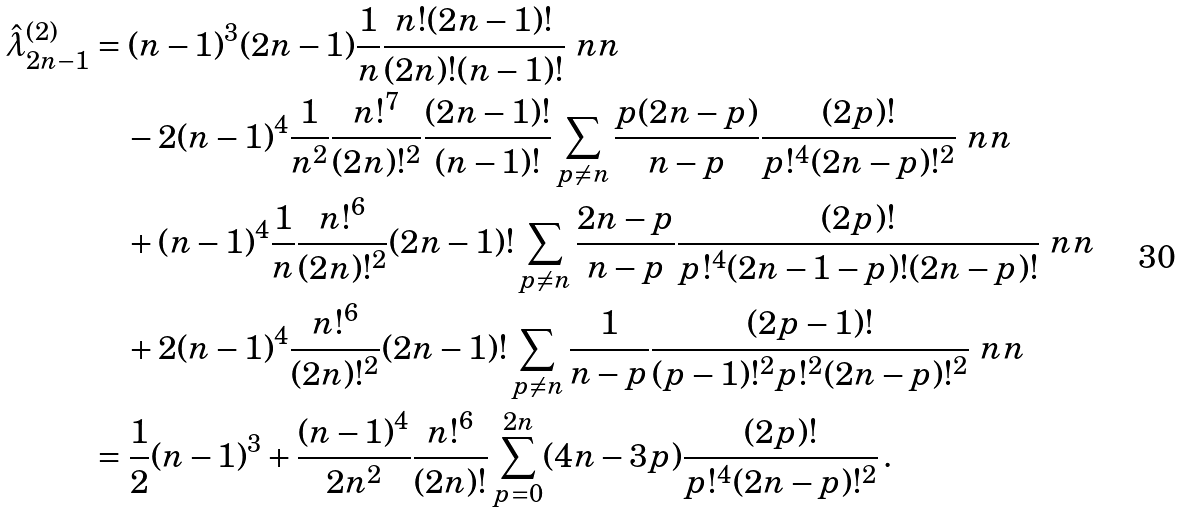<formula> <loc_0><loc_0><loc_500><loc_500>\hat { \lambda } _ { 2 n - 1 } ^ { ( 2 ) } & = ( n - 1 ) ^ { 3 } ( 2 n - 1 ) \frac { 1 } { n } \frac { n ! ( 2 n - 1 ) ! } { ( 2 n ) ! ( n - 1 ) ! } \ n n \\ & \quad - 2 ( n - 1 ) ^ { 4 } \frac { 1 } { n ^ { 2 } } \frac { n ! ^ { 7 } } { ( 2 n ) ! ^ { 2 } } \frac { ( 2 n - 1 ) ! } { ( n - 1 ) ! } \sum _ { p \neq n } \frac { p ( 2 n - p ) } { n - p } \frac { ( 2 p ) ! } { p ! ^ { 4 } ( 2 n - p ) ! ^ { 2 } } \ n n \\ & \quad + ( n - 1 ) ^ { 4 } \frac { 1 } { n } \frac { n ! ^ { 6 } } { ( 2 n ) ! ^ { 2 } } ( 2 n - 1 ) ! \sum _ { p \neq n } \frac { 2 n - p } { n - p } \frac { ( 2 p ) ! } { p ! ^ { 4 } ( 2 n - 1 - p ) ! ( 2 n - p ) ! } \ n n \\ & \quad + 2 ( n - 1 ) ^ { 4 } \frac { n ! ^ { 6 } } { ( 2 n ) ! ^ { 2 } } ( 2 n - 1 ) ! \sum _ { p \neq n } \frac { 1 } { n - p } \frac { ( 2 p - 1 ) ! } { ( p - 1 ) ! ^ { 2 } p ! ^ { 2 } ( 2 n - p ) ! ^ { 2 } } \ n n \\ & = \frac { 1 } { 2 } ( n - 1 ) ^ { 3 } + \frac { ( n - 1 ) ^ { 4 } } { 2 n ^ { 2 } } \frac { n ! ^ { 6 } } { ( 2 n ) ! } \sum _ { p = 0 } ^ { 2 n } ( 4 n - 3 p ) \frac { ( 2 p ) ! } { p ! ^ { 4 } ( 2 n - p ) ! ^ { 2 } } \, .</formula> 